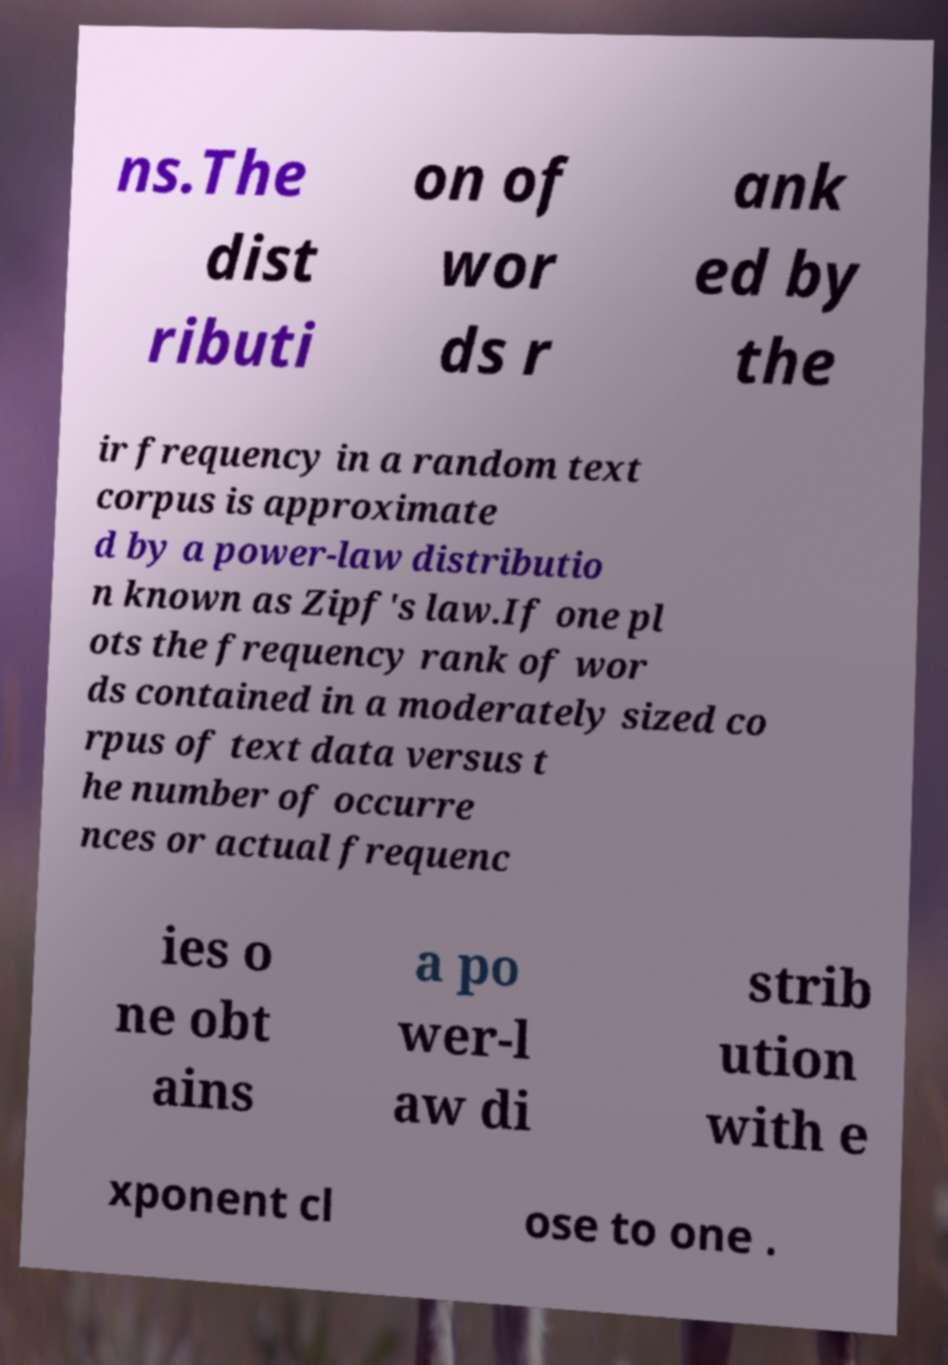I need the written content from this picture converted into text. Can you do that? ns.The dist ributi on of wor ds r ank ed by the ir frequency in a random text corpus is approximate d by a power-law distributio n known as Zipf's law.If one pl ots the frequency rank of wor ds contained in a moderately sized co rpus of text data versus t he number of occurre nces or actual frequenc ies o ne obt ains a po wer-l aw di strib ution with e xponent cl ose to one . 